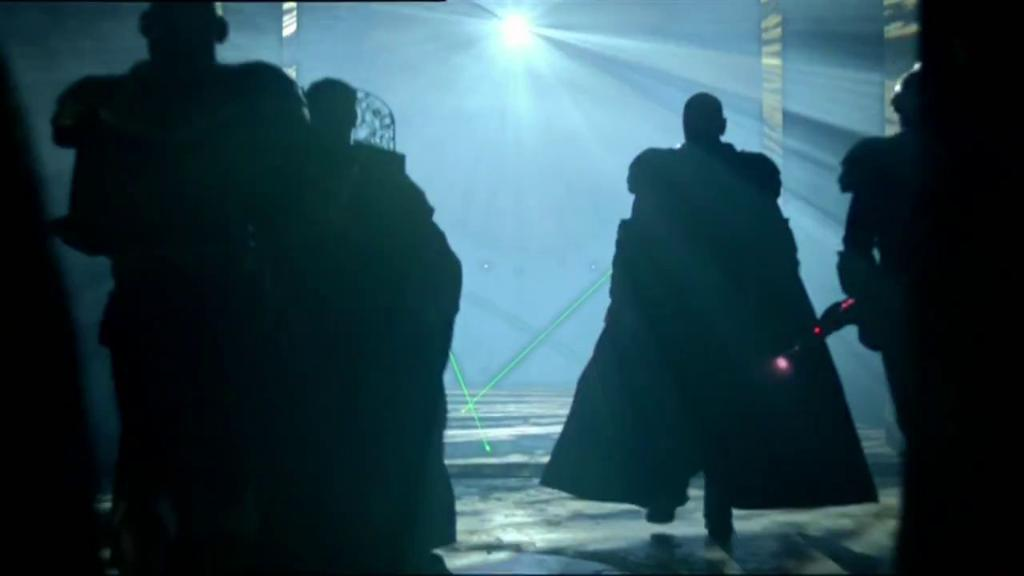How many people are in the image? There is a group of people in the image, but the exact number is not specified. What are the people doing in the image? The people are standing on the floor in the image. What can be seen in the background of the image? There is light visible in the background of the image. How many bridges can be seen in the image? There are no bridges present in the image. What type of air is visible in the image? There is no specific type of air visible in the image; it is simply the ambient air. What muscles are being flexed by the people in the image? The facts provided do not give any information about the people's muscles or their physical activity, so it cannot be determined from the image. 